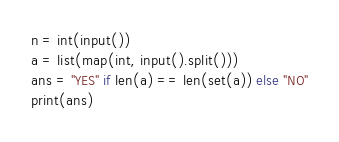Convert code to text. <code><loc_0><loc_0><loc_500><loc_500><_Python_>n = int(input())
a = list(map(int, input().split()))
ans = "YES" if len(a) == len(set(a)) else "NO"
print(ans)
</code> 